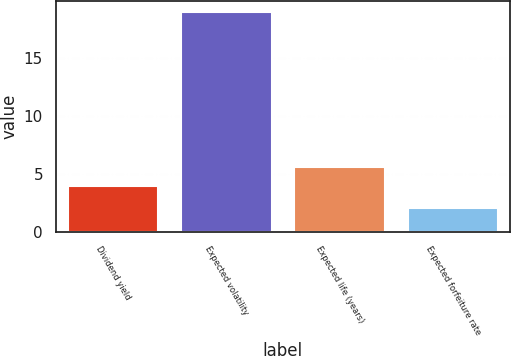<chart> <loc_0><loc_0><loc_500><loc_500><bar_chart><fcel>Dividend yield<fcel>Expected volatility<fcel>Expected life (years)<fcel>Expected forfeiture rate<nl><fcel>3.9<fcel>19<fcel>5.6<fcel>2<nl></chart> 